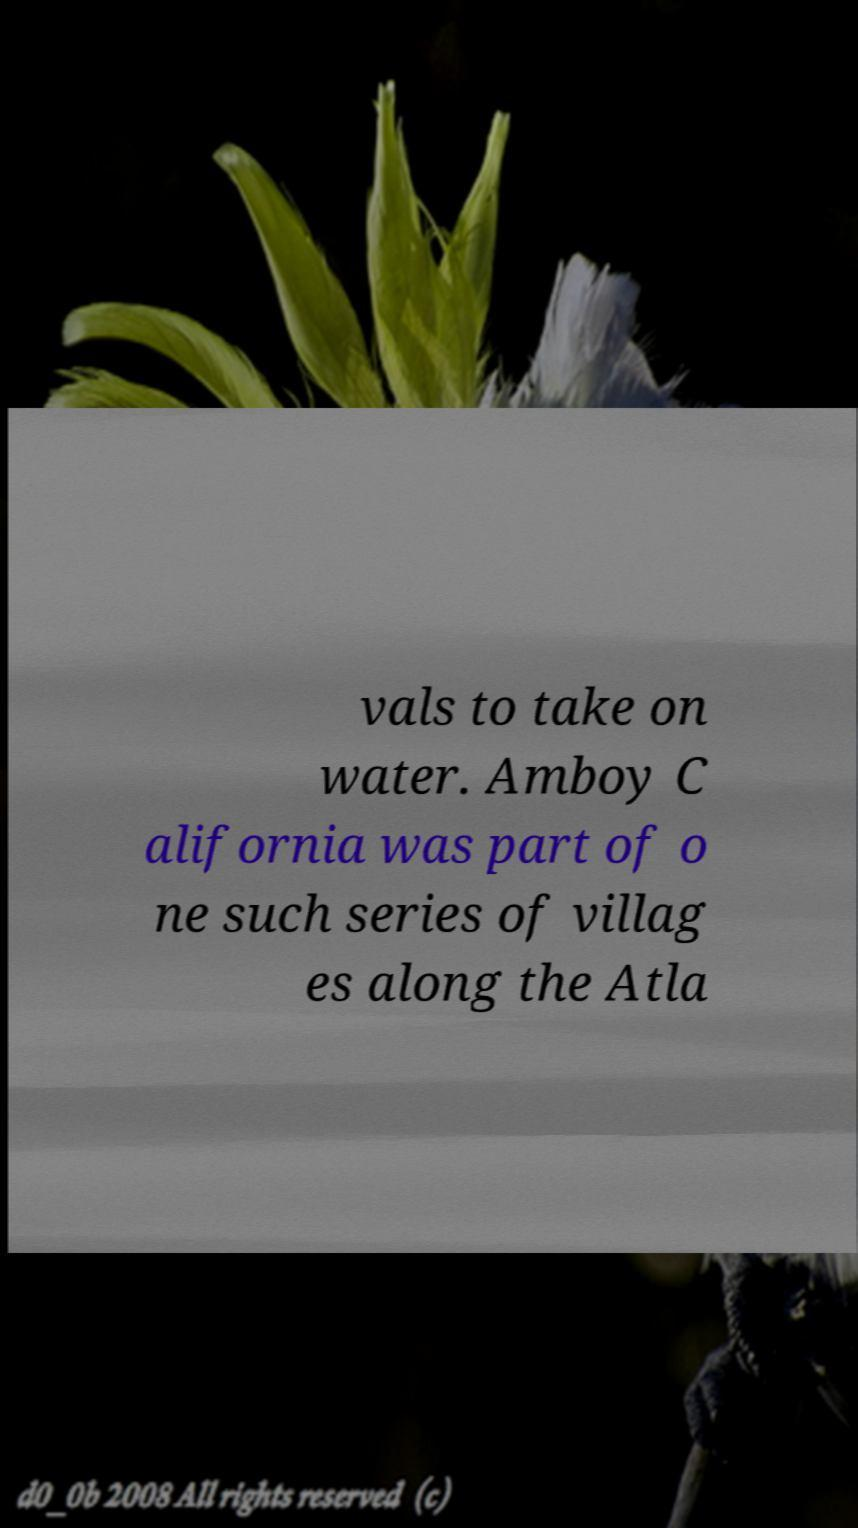There's text embedded in this image that I need extracted. Can you transcribe it verbatim? vals to take on water. Amboy C alifornia was part of o ne such series of villag es along the Atla 